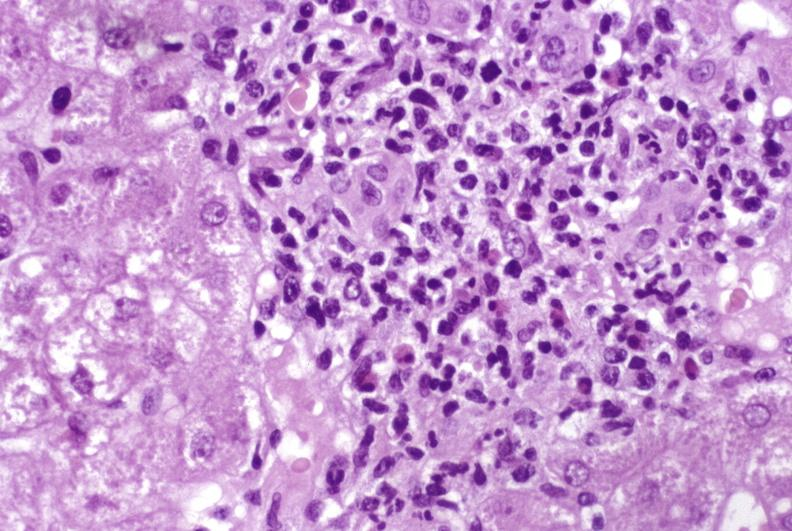what does this image show?
Answer the question using a single word or phrase. Moderate acute rejection 